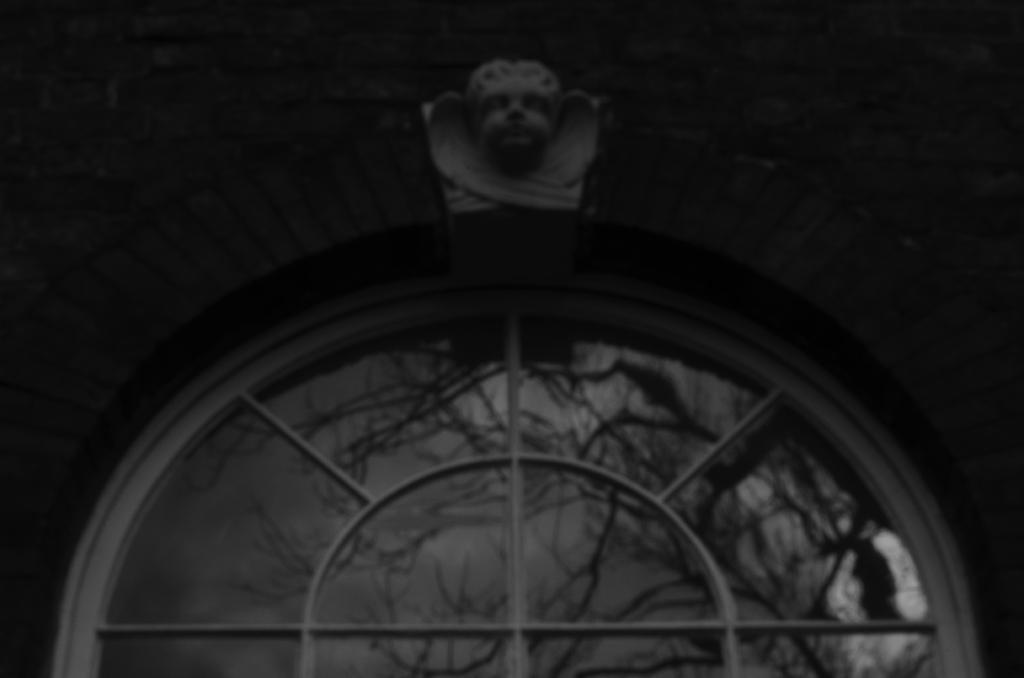Could you give a brief overview of what you see in this image? In this image we can see a wall. On the wall we can see a sculpture. Below the sculpture, we can see a window with a glass. 